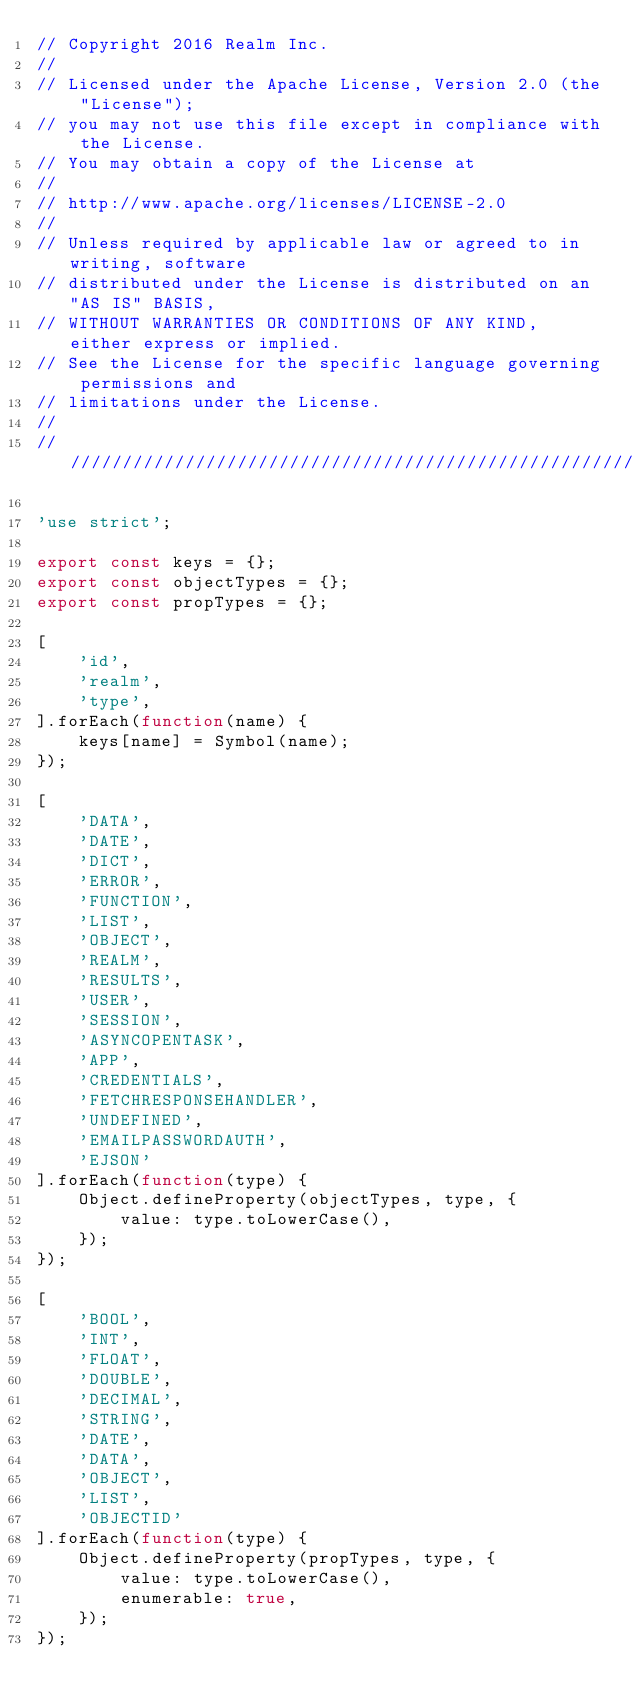Convert code to text. <code><loc_0><loc_0><loc_500><loc_500><_JavaScript_>// Copyright 2016 Realm Inc.
//
// Licensed under the Apache License, Version 2.0 (the "License");
// you may not use this file except in compliance with the License.
// You may obtain a copy of the License at
//
// http://www.apache.org/licenses/LICENSE-2.0
//
// Unless required by applicable law or agreed to in writing, software
// distributed under the License is distributed on an "AS IS" BASIS,
// WITHOUT WARRANTIES OR CONDITIONS OF ANY KIND, either express or implied.
// See the License for the specific language governing permissions and
// limitations under the License.
//
////////////////////////////////////////////////////////////////////////////

'use strict';

export const keys = {};
export const objectTypes = {};
export const propTypes = {};

[
    'id',
    'realm',
    'type',
].forEach(function(name) {
    keys[name] = Symbol(name);
});

[
    'DATA',
    'DATE',
    'DICT',
    'ERROR',
    'FUNCTION',
    'LIST',
    'OBJECT',
    'REALM',
    'RESULTS',
    'USER',
    'SESSION',
    'ASYNCOPENTASK',
    'APP',
    'CREDENTIALS',
    'FETCHRESPONSEHANDLER',
    'UNDEFINED',
    'EMAILPASSWORDAUTH',
    'EJSON'
].forEach(function(type) {
    Object.defineProperty(objectTypes, type, {
        value: type.toLowerCase(),
    });
});

[
    'BOOL',
    'INT',
    'FLOAT',
    'DOUBLE',
    'DECIMAL',
    'STRING',
    'DATE',
    'DATA',
    'OBJECT',
    'LIST',
    'OBJECTID'
].forEach(function(type) {
    Object.defineProperty(propTypes, type, {
        value: type.toLowerCase(),
        enumerable: true,
    });
});
</code> 